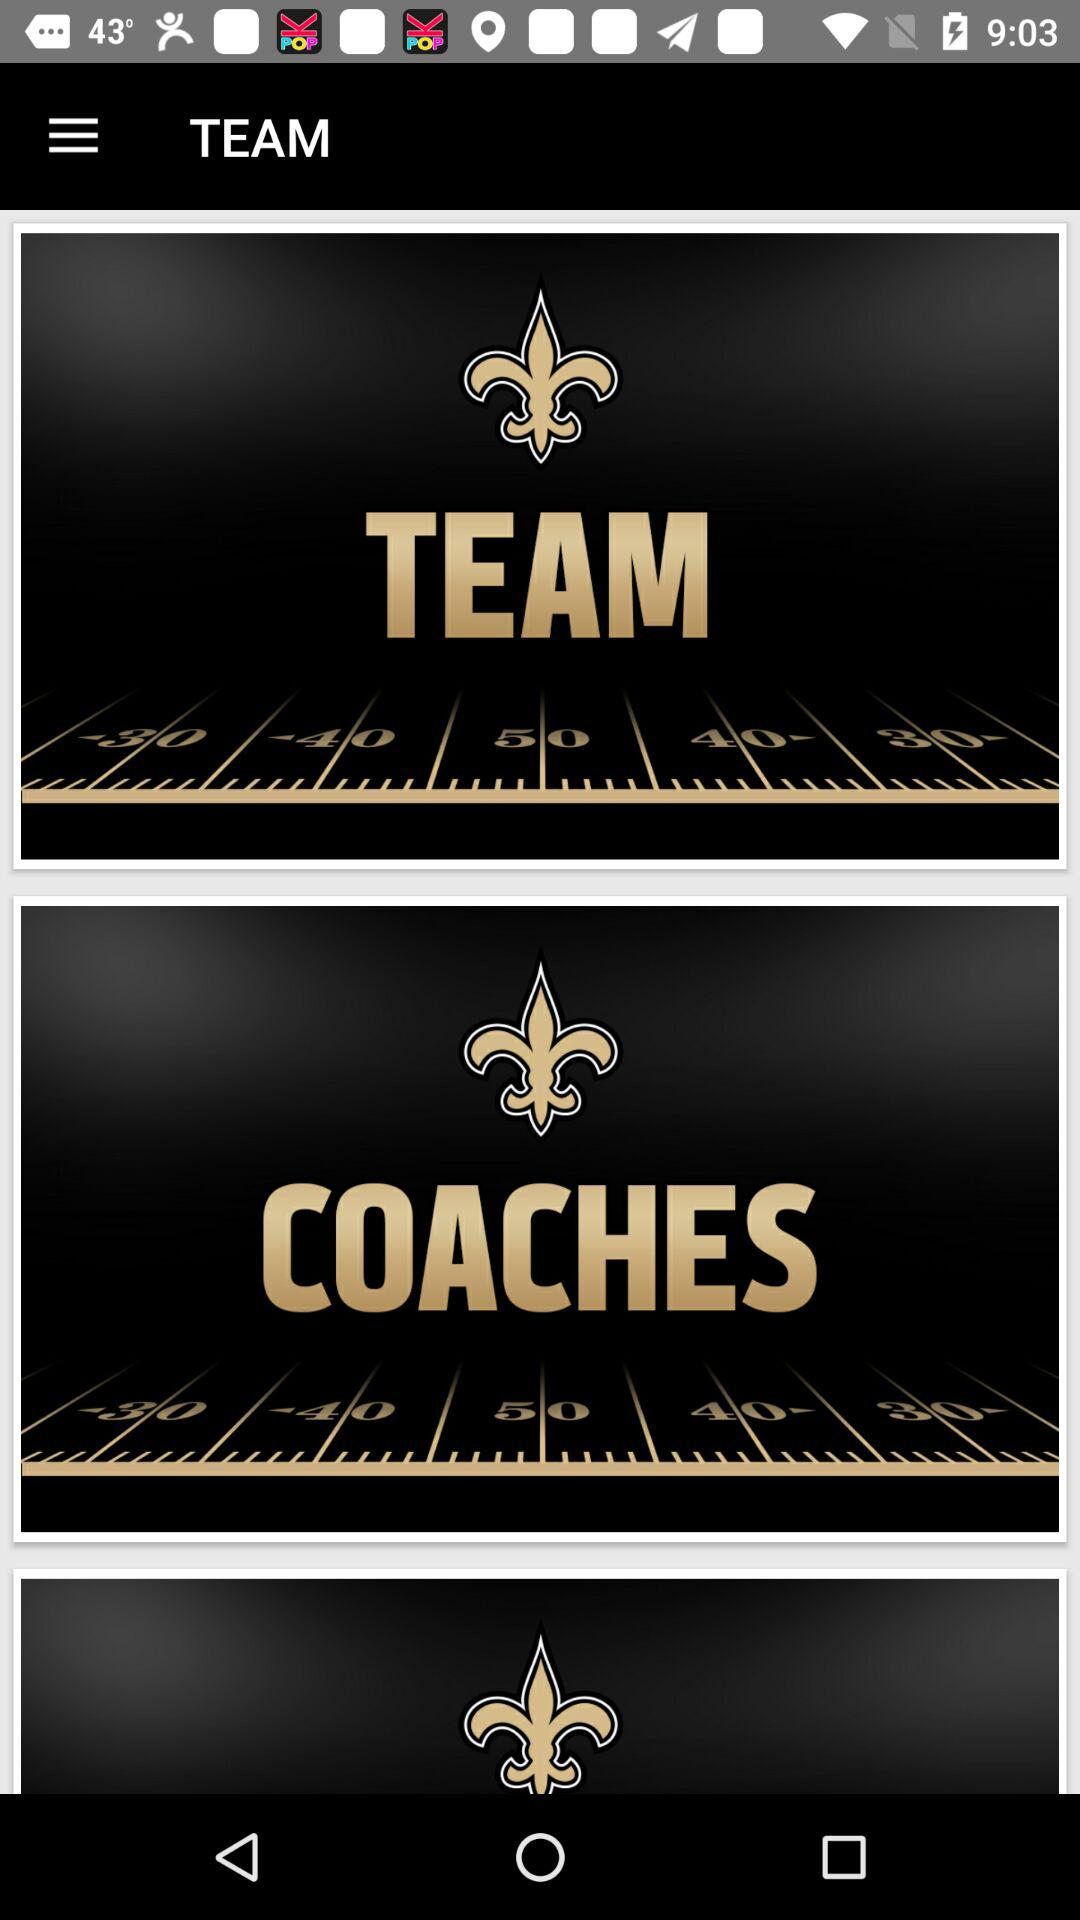How many fleur de lis are displayed?
Answer the question using a single word or phrase. 3 